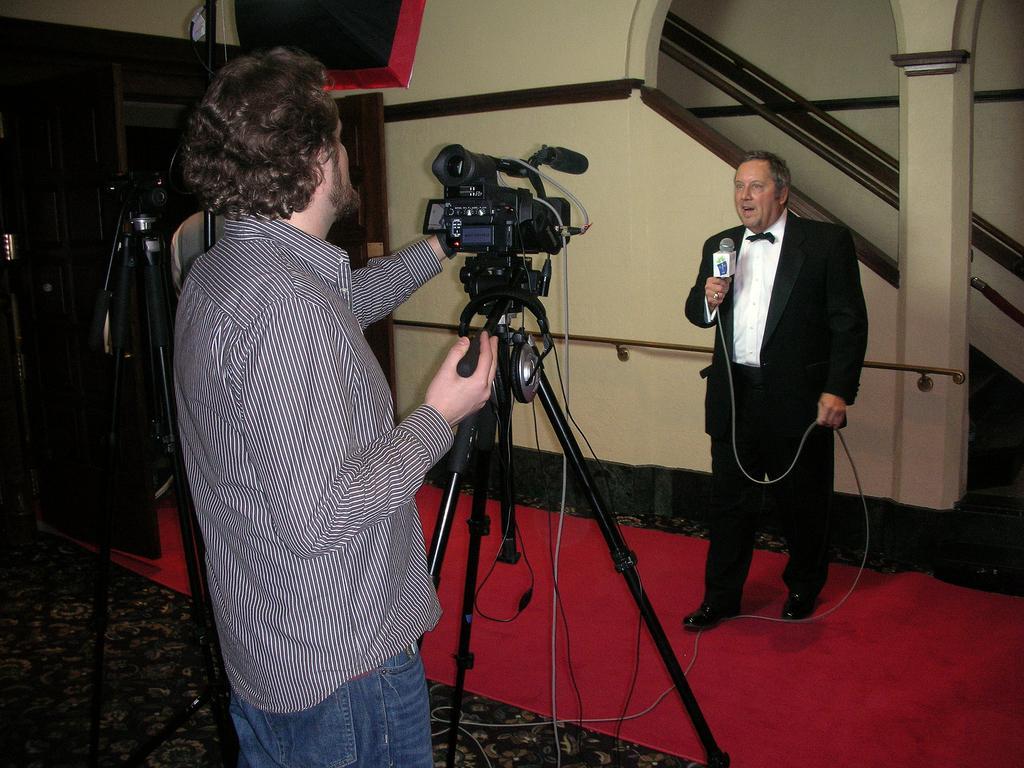Could you give a brief overview of what you see in this image? This picture shows a man holding a camera in his hand and a man standing in front of it and speaking with the help of a microphone. 